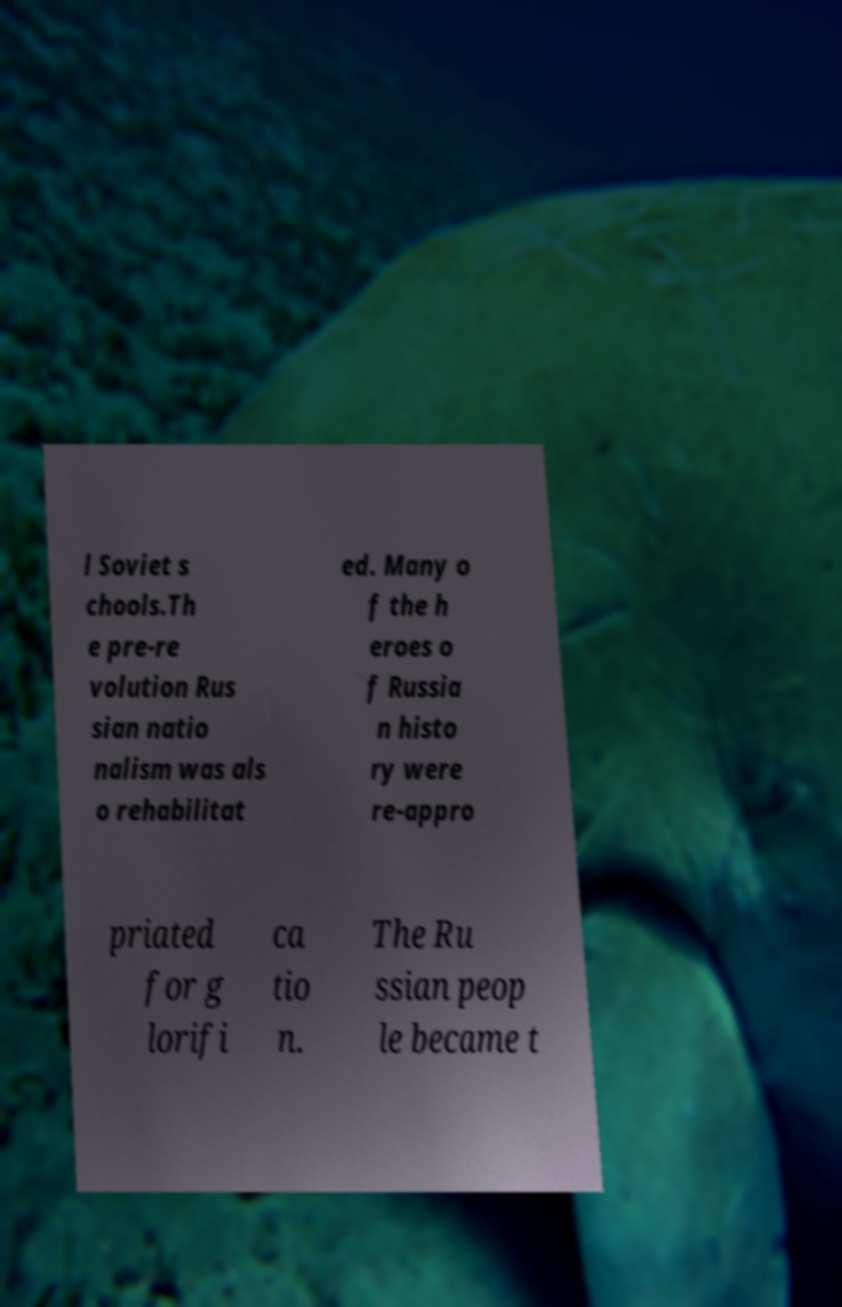Can you read and provide the text displayed in the image?This photo seems to have some interesting text. Can you extract and type it out for me? l Soviet s chools.Th e pre-re volution Rus sian natio nalism was als o rehabilitat ed. Many o f the h eroes o f Russia n histo ry were re-appro priated for g lorifi ca tio n. The Ru ssian peop le became t 